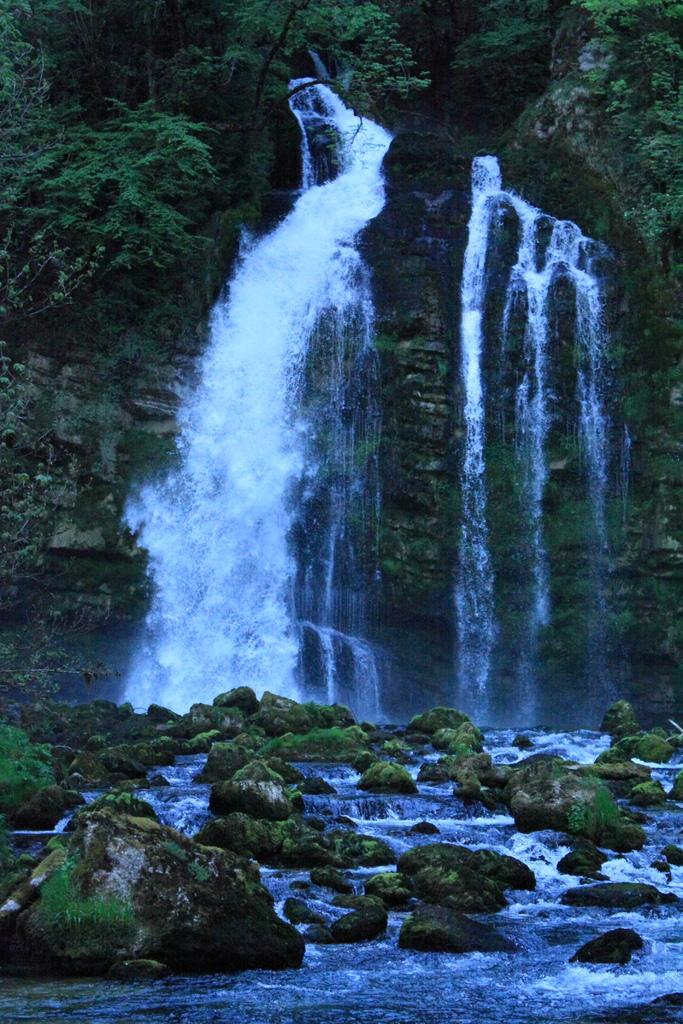What natural feature is the main subject of the image? There is a waterfall in the image. Where does the waterfall originate from? The waterfall originates from hills. What can be seen growing on the hills? There are plants on the hills. What is visible at the bottom of the waterfall? Water is visible at the bottom of the waterfall. What else can be seen at the bottom of the waterfall? There are rocks visible at the bottom of the waterfall. What is the waterfall angry about in the image? The waterfall is not capable of feeling emotions like anger; it is a natural feature. 